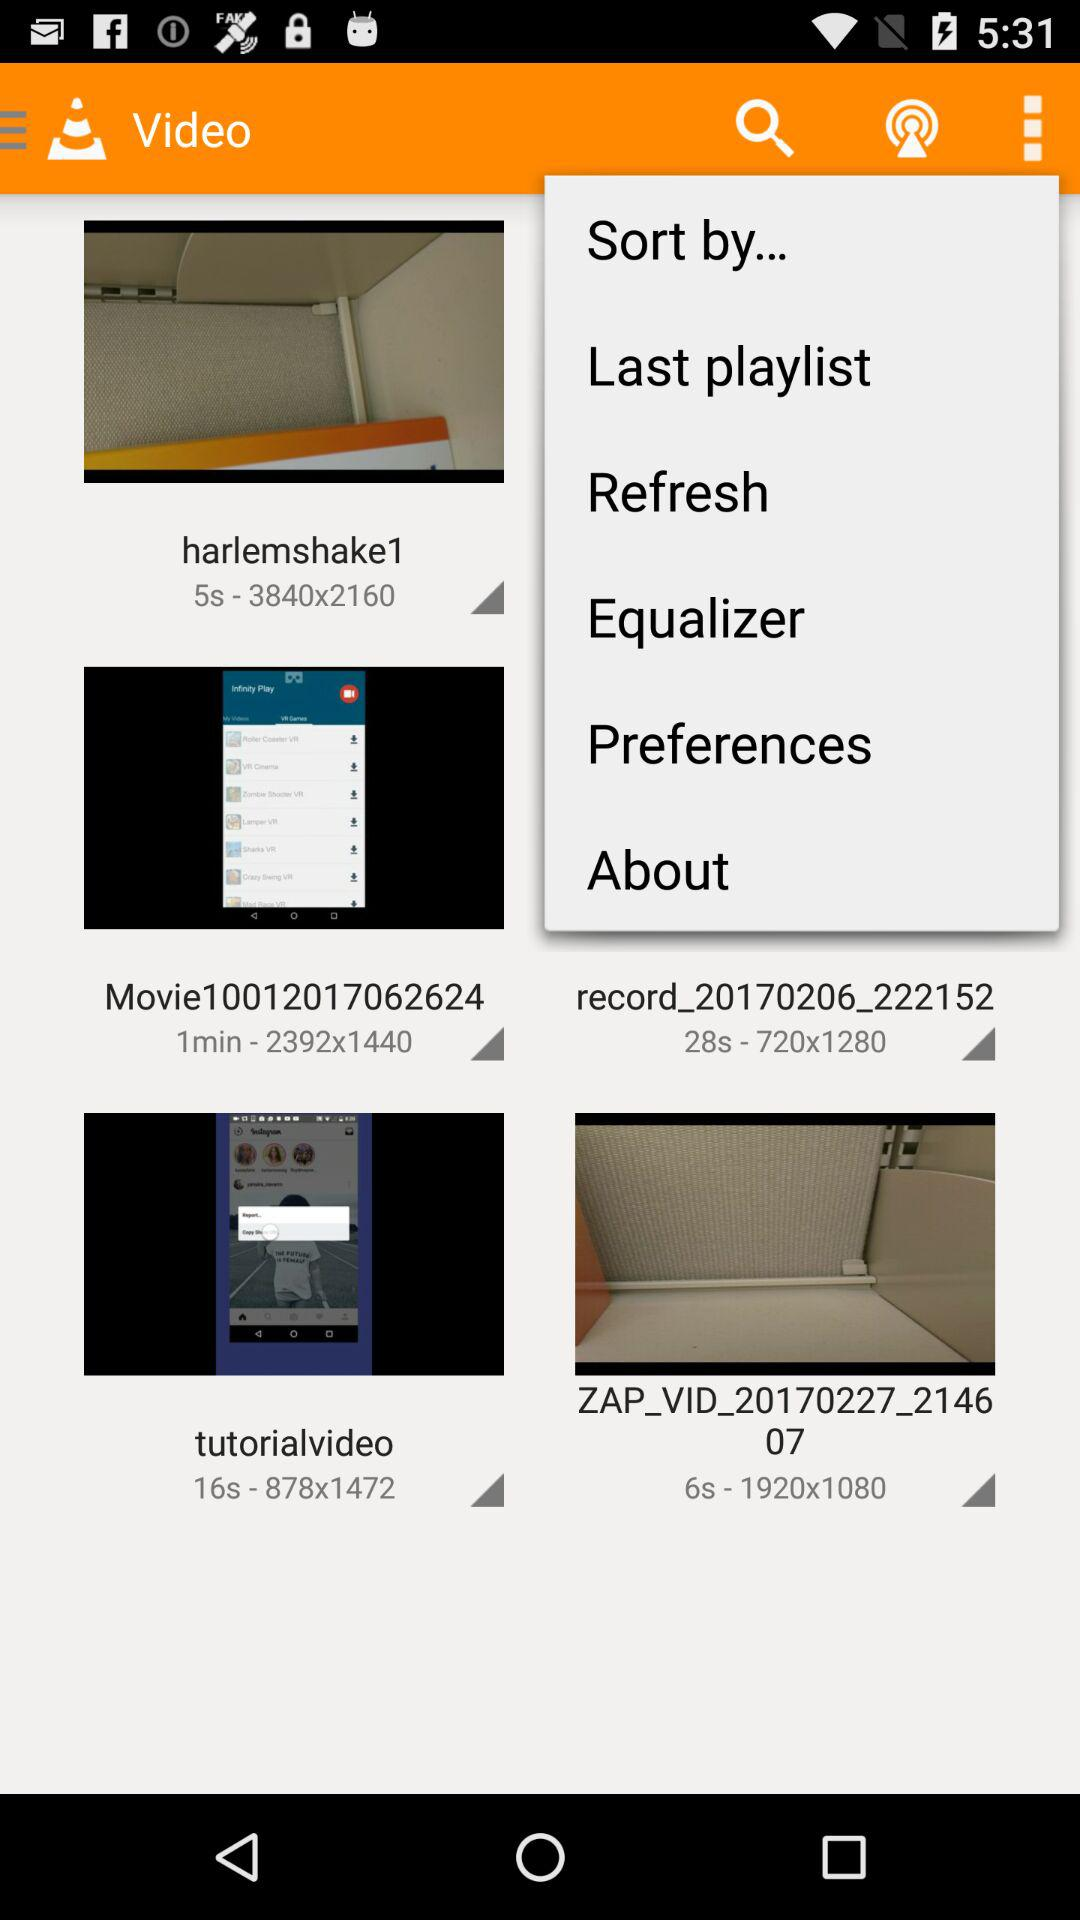What is the duration of the "tutorialvideo"? The duration of the video is 16 seconds. 